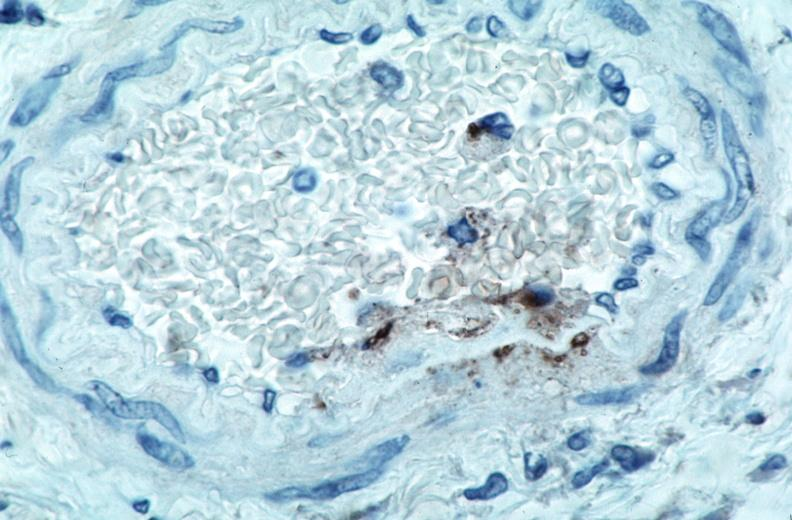does anencephaly show vasculitis?
Answer the question using a single word or phrase. No 